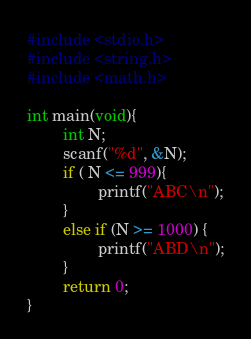Convert code to text. <code><loc_0><loc_0><loc_500><loc_500><_C_>#include <stdio.h>
#include <string.h>
#include <math.h>

int main(void){
        int N;
        scanf("%d", &N);
        if ( N <= 999){
                printf("ABC\n");
        }
        else if (N >= 1000) {
                printf("ABD\n");
        }
        return 0;
}</code> 